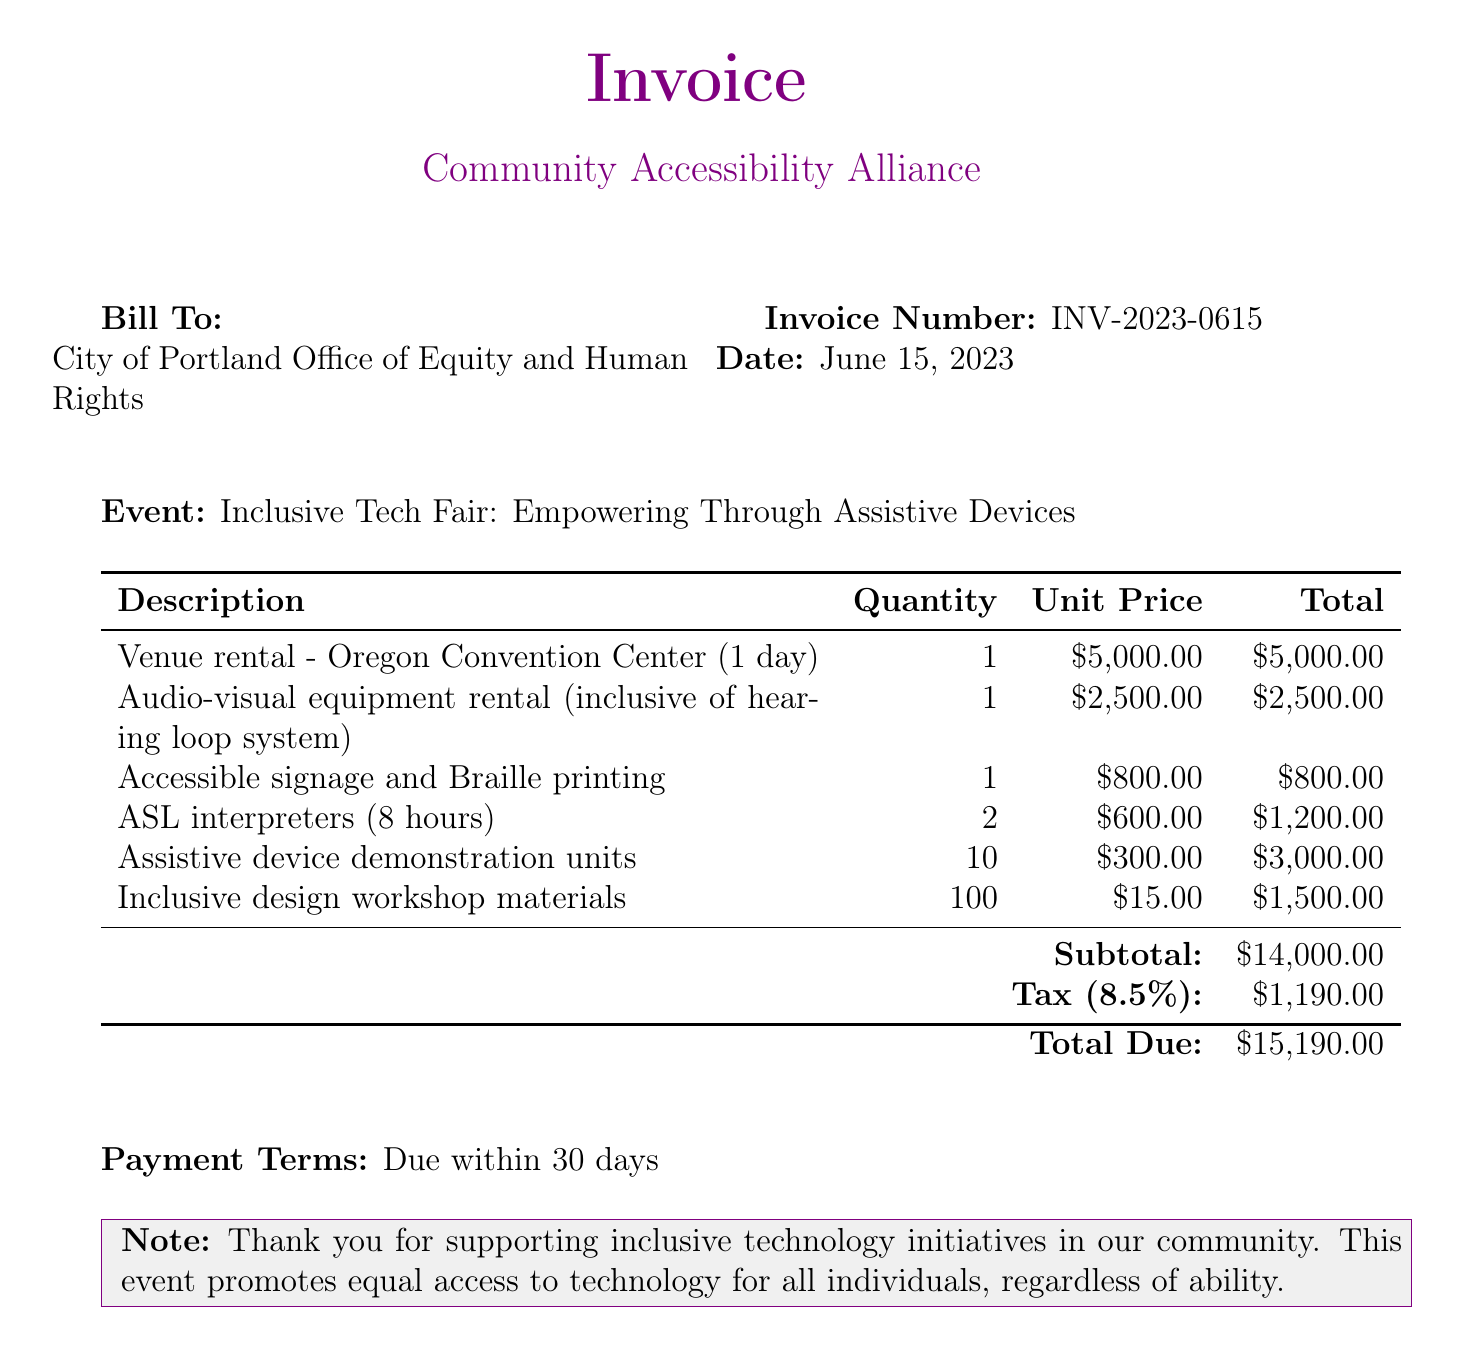what is the invoice number? The invoice number is a unique identifier for the bill, specified in the document.
Answer: INV-2023-0615 what is the date of the invoice? The document states the date when the invoice was issued.
Answer: June 15, 2023 who is billed in this invoice? The entity listed as the recipient or payer of the invoice is mentioned in the document.
Answer: City of Portland Office of Equity and Human Rights what is the subtotal amount? The subtotal is the total of all line items before tax is added, explicitly provided in the document.
Answer: $14,000.00 how much is charged for ASL interpreters? The document specifies the total cost associated with ASL interpreters based on quantity and unit price.
Answer: $1,200.00 what percentage tax is applied to the subtotal? The tax percentage is noted in the document related to the total amount due.
Answer: 8.5% how many assistive device demonstration units are included? The total quantity of assistive device units is mentioned in the line item in the document.
Answer: 10 what is the total amount due? The total due incorporates the subtotal and tax, indicated at the end of the invoice.
Answer: $15,190.00 what is the payment term mentioned in the invoice? The document specifies the time frame within which payment should be made.
Answer: Due within 30 days 